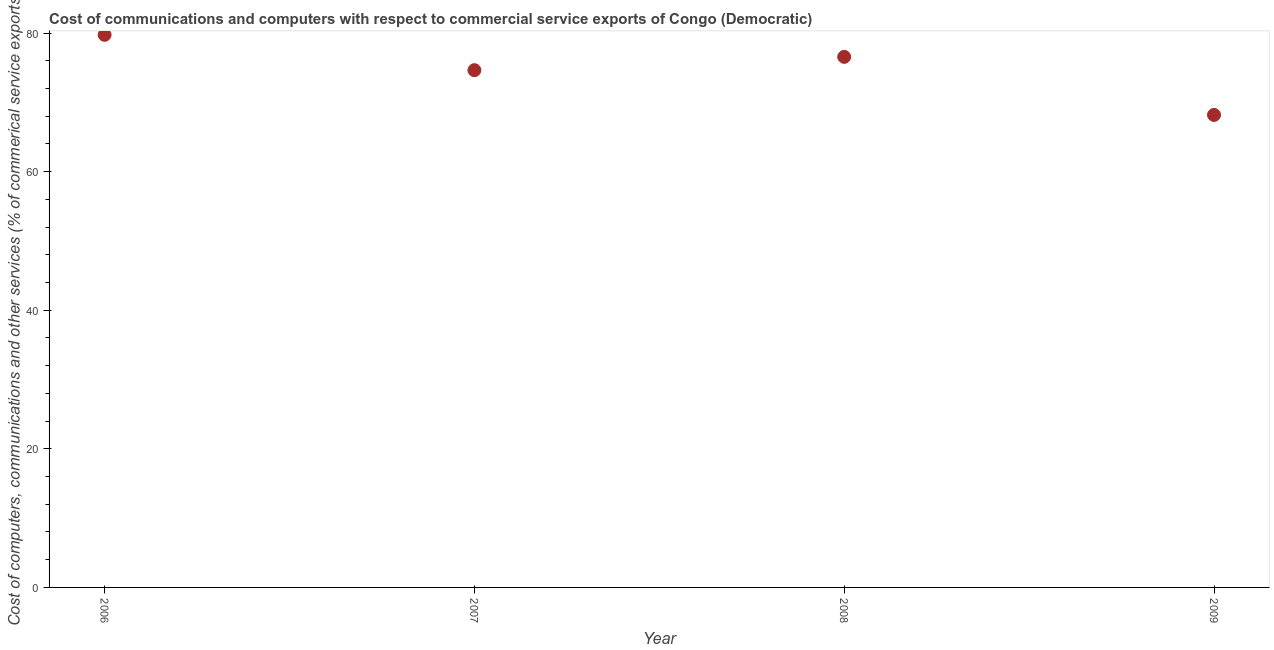What is the cost of communications in 2007?
Provide a succinct answer. 74.65. Across all years, what is the maximum  computer and other services?
Offer a very short reply. 79.75. Across all years, what is the minimum  computer and other services?
Keep it short and to the point. 68.19. What is the sum of the cost of communications?
Provide a short and direct response. 299.18. What is the difference between the cost of communications in 2006 and 2009?
Give a very brief answer. 11.56. What is the average cost of communications per year?
Offer a very short reply. 74.79. What is the median cost of communications?
Provide a succinct answer. 75.61. What is the ratio of the cost of communications in 2008 to that in 2009?
Offer a very short reply. 1.12. What is the difference between the highest and the second highest  computer and other services?
Provide a short and direct response. 3.18. Is the sum of the cost of communications in 2008 and 2009 greater than the maximum cost of communications across all years?
Your answer should be compact. Yes. What is the difference between the highest and the lowest cost of communications?
Provide a short and direct response. 11.56. Does the cost of communications monotonically increase over the years?
Offer a very short reply. No. How many years are there in the graph?
Offer a very short reply. 4. Are the values on the major ticks of Y-axis written in scientific E-notation?
Your answer should be compact. No. What is the title of the graph?
Give a very brief answer. Cost of communications and computers with respect to commercial service exports of Congo (Democratic). What is the label or title of the Y-axis?
Your response must be concise. Cost of computers, communications and other services (% of commerical service exports). What is the Cost of computers, communications and other services (% of commerical service exports) in 2006?
Make the answer very short. 79.75. What is the Cost of computers, communications and other services (% of commerical service exports) in 2007?
Your answer should be very brief. 74.65. What is the Cost of computers, communications and other services (% of commerical service exports) in 2008?
Give a very brief answer. 76.57. What is the Cost of computers, communications and other services (% of commerical service exports) in 2009?
Your answer should be very brief. 68.19. What is the difference between the Cost of computers, communications and other services (% of commerical service exports) in 2006 and 2007?
Give a very brief answer. 5.1. What is the difference between the Cost of computers, communications and other services (% of commerical service exports) in 2006 and 2008?
Make the answer very short. 3.18. What is the difference between the Cost of computers, communications and other services (% of commerical service exports) in 2006 and 2009?
Ensure brevity in your answer.  11.56. What is the difference between the Cost of computers, communications and other services (% of commerical service exports) in 2007 and 2008?
Your answer should be compact. -1.92. What is the difference between the Cost of computers, communications and other services (% of commerical service exports) in 2007 and 2009?
Keep it short and to the point. 6.46. What is the difference between the Cost of computers, communications and other services (% of commerical service exports) in 2008 and 2009?
Give a very brief answer. 8.38. What is the ratio of the Cost of computers, communications and other services (% of commerical service exports) in 2006 to that in 2007?
Give a very brief answer. 1.07. What is the ratio of the Cost of computers, communications and other services (% of commerical service exports) in 2006 to that in 2008?
Provide a succinct answer. 1.04. What is the ratio of the Cost of computers, communications and other services (% of commerical service exports) in 2006 to that in 2009?
Your answer should be very brief. 1.17. What is the ratio of the Cost of computers, communications and other services (% of commerical service exports) in 2007 to that in 2009?
Provide a succinct answer. 1.09. What is the ratio of the Cost of computers, communications and other services (% of commerical service exports) in 2008 to that in 2009?
Give a very brief answer. 1.12. 